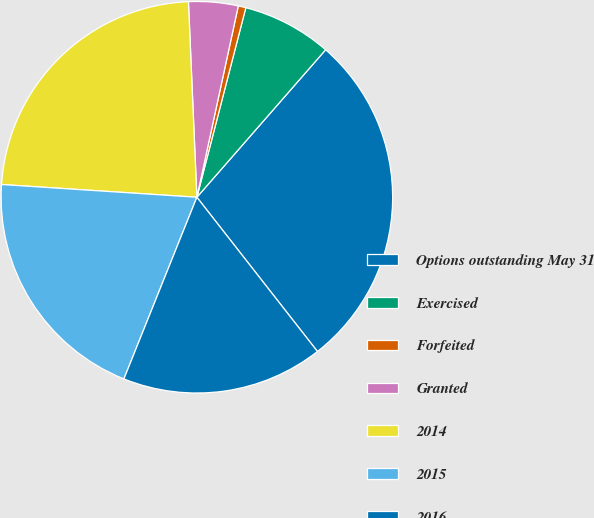Convert chart to OTSL. <chart><loc_0><loc_0><loc_500><loc_500><pie_chart><fcel>Options outstanding May 31<fcel>Exercised<fcel>Forfeited<fcel>Granted<fcel>2014<fcel>2015<fcel>2016<nl><fcel>28.02%<fcel>7.4%<fcel>0.63%<fcel>4.08%<fcel>23.28%<fcel>19.96%<fcel>16.64%<nl></chart> 